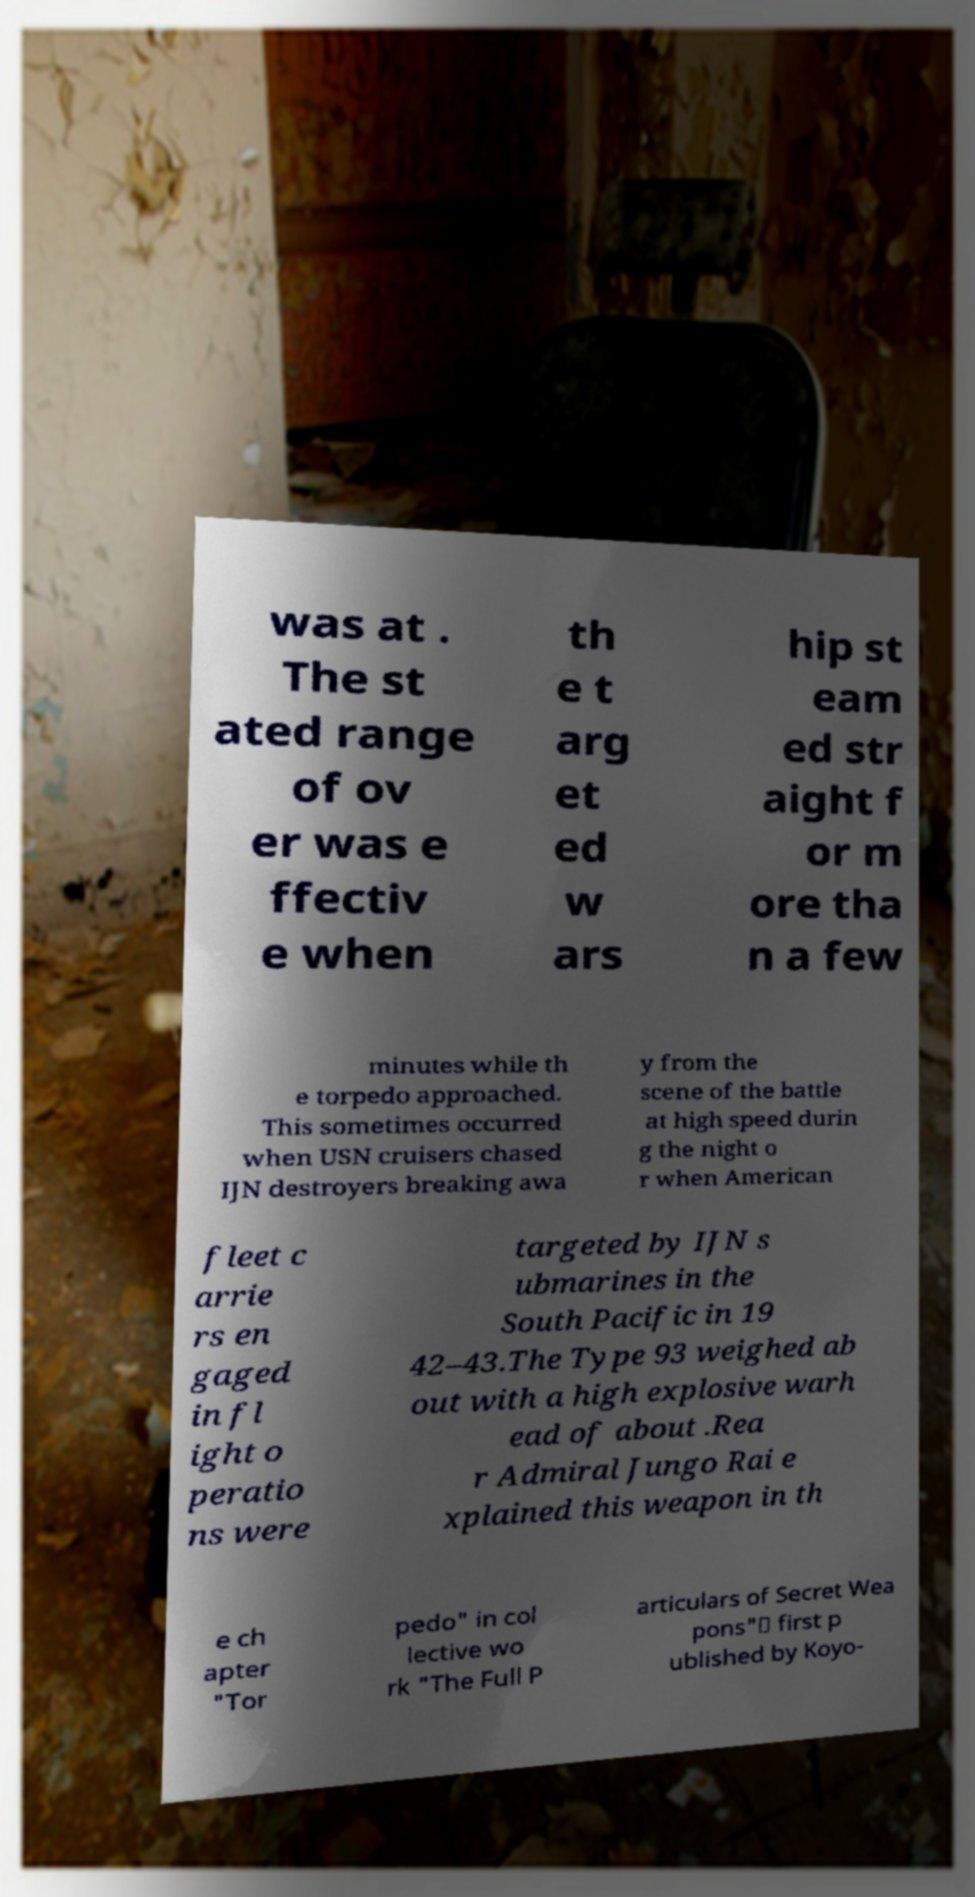Could you assist in decoding the text presented in this image and type it out clearly? was at . The st ated range of ov er was e ffectiv e when th e t arg et ed w ars hip st eam ed str aight f or m ore tha n a few minutes while th e torpedo approached. This sometimes occurred when USN cruisers chased IJN destroyers breaking awa y from the scene of the battle at high speed durin g the night o r when American fleet c arrie rs en gaged in fl ight o peratio ns were targeted by IJN s ubmarines in the South Pacific in 19 42–43.The Type 93 weighed ab out with a high explosive warh ead of about .Rea r Admiral Jungo Rai e xplained this weapon in th e ch apter "Tor pedo" in col lective wo rk "The Full P articulars of Secret Wea pons"（ first p ublished by Koyo- 